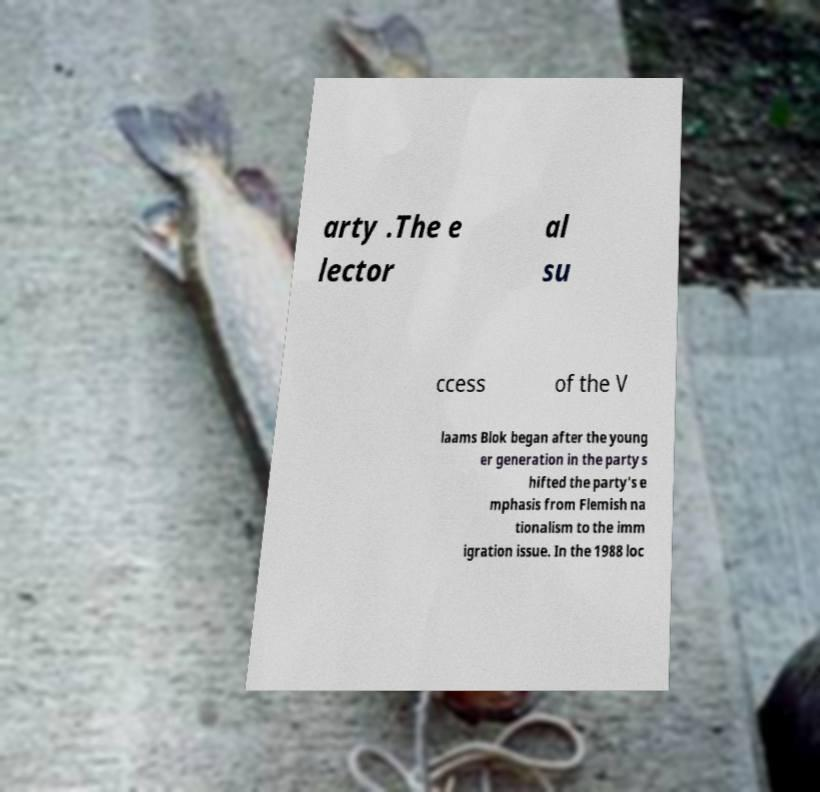There's text embedded in this image that I need extracted. Can you transcribe it verbatim? arty .The e lector al su ccess of the V laams Blok began after the young er generation in the party s hifted the party's e mphasis from Flemish na tionalism to the imm igration issue. In the 1988 loc 